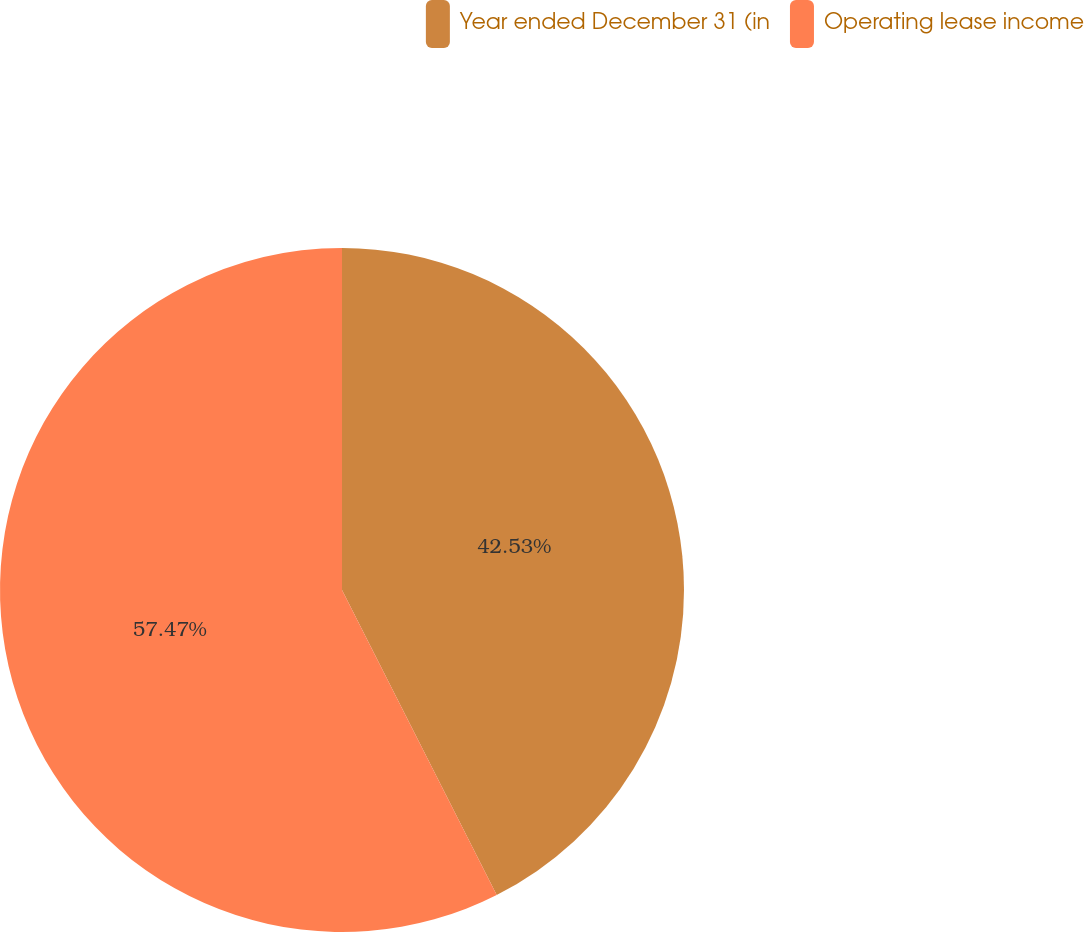<chart> <loc_0><loc_0><loc_500><loc_500><pie_chart><fcel>Year ended December 31 (in<fcel>Operating lease income<nl><fcel>42.53%<fcel>57.47%<nl></chart> 